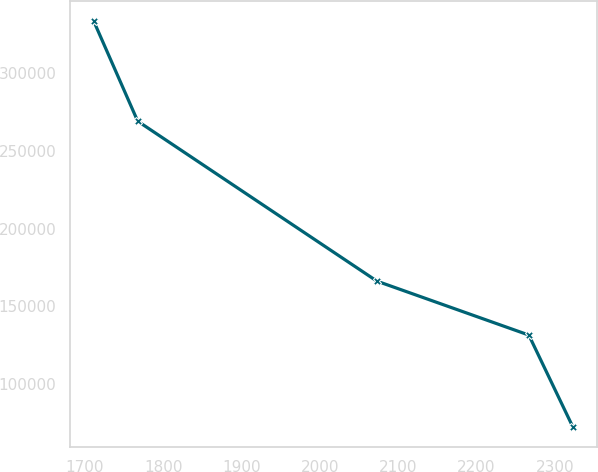Convert chart. <chart><loc_0><loc_0><loc_500><loc_500><line_chart><ecel><fcel>Unnamed: 1<nl><fcel>1711.12<fcel>333202<nl><fcel>1767.33<fcel>268932<nl><fcel>2072.81<fcel>166260<nl><fcel>2266.73<fcel>131675<nl><fcel>2322.94<fcel>72703.2<nl></chart> 